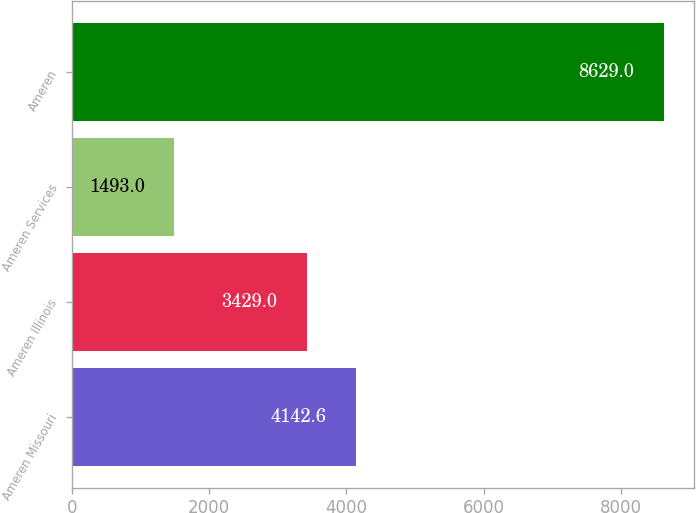<chart> <loc_0><loc_0><loc_500><loc_500><bar_chart><fcel>Ameren Missouri<fcel>Ameren Illinois<fcel>Ameren Services<fcel>Ameren<nl><fcel>4142.6<fcel>3429<fcel>1493<fcel>8629<nl></chart> 